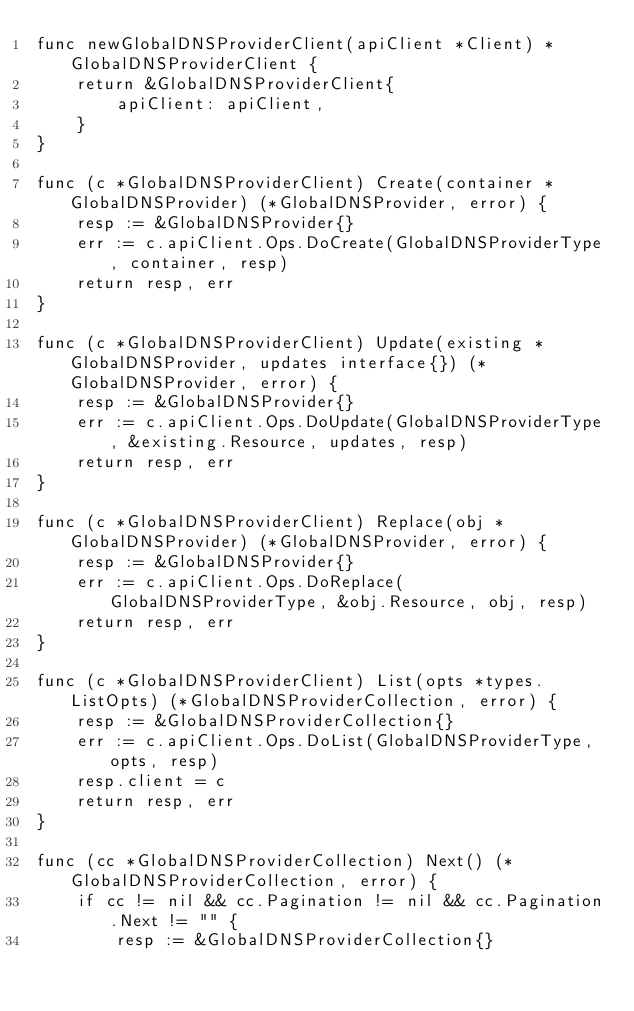<code> <loc_0><loc_0><loc_500><loc_500><_Go_>func newGlobalDNSProviderClient(apiClient *Client) *GlobalDNSProviderClient {
	return &GlobalDNSProviderClient{
		apiClient: apiClient,
	}
}

func (c *GlobalDNSProviderClient) Create(container *GlobalDNSProvider) (*GlobalDNSProvider, error) {
	resp := &GlobalDNSProvider{}
	err := c.apiClient.Ops.DoCreate(GlobalDNSProviderType, container, resp)
	return resp, err
}

func (c *GlobalDNSProviderClient) Update(existing *GlobalDNSProvider, updates interface{}) (*GlobalDNSProvider, error) {
	resp := &GlobalDNSProvider{}
	err := c.apiClient.Ops.DoUpdate(GlobalDNSProviderType, &existing.Resource, updates, resp)
	return resp, err
}

func (c *GlobalDNSProviderClient) Replace(obj *GlobalDNSProvider) (*GlobalDNSProvider, error) {
	resp := &GlobalDNSProvider{}
	err := c.apiClient.Ops.DoReplace(GlobalDNSProviderType, &obj.Resource, obj, resp)
	return resp, err
}

func (c *GlobalDNSProviderClient) List(opts *types.ListOpts) (*GlobalDNSProviderCollection, error) {
	resp := &GlobalDNSProviderCollection{}
	err := c.apiClient.Ops.DoList(GlobalDNSProviderType, opts, resp)
	resp.client = c
	return resp, err
}

func (cc *GlobalDNSProviderCollection) Next() (*GlobalDNSProviderCollection, error) {
	if cc != nil && cc.Pagination != nil && cc.Pagination.Next != "" {
		resp := &GlobalDNSProviderCollection{}</code> 